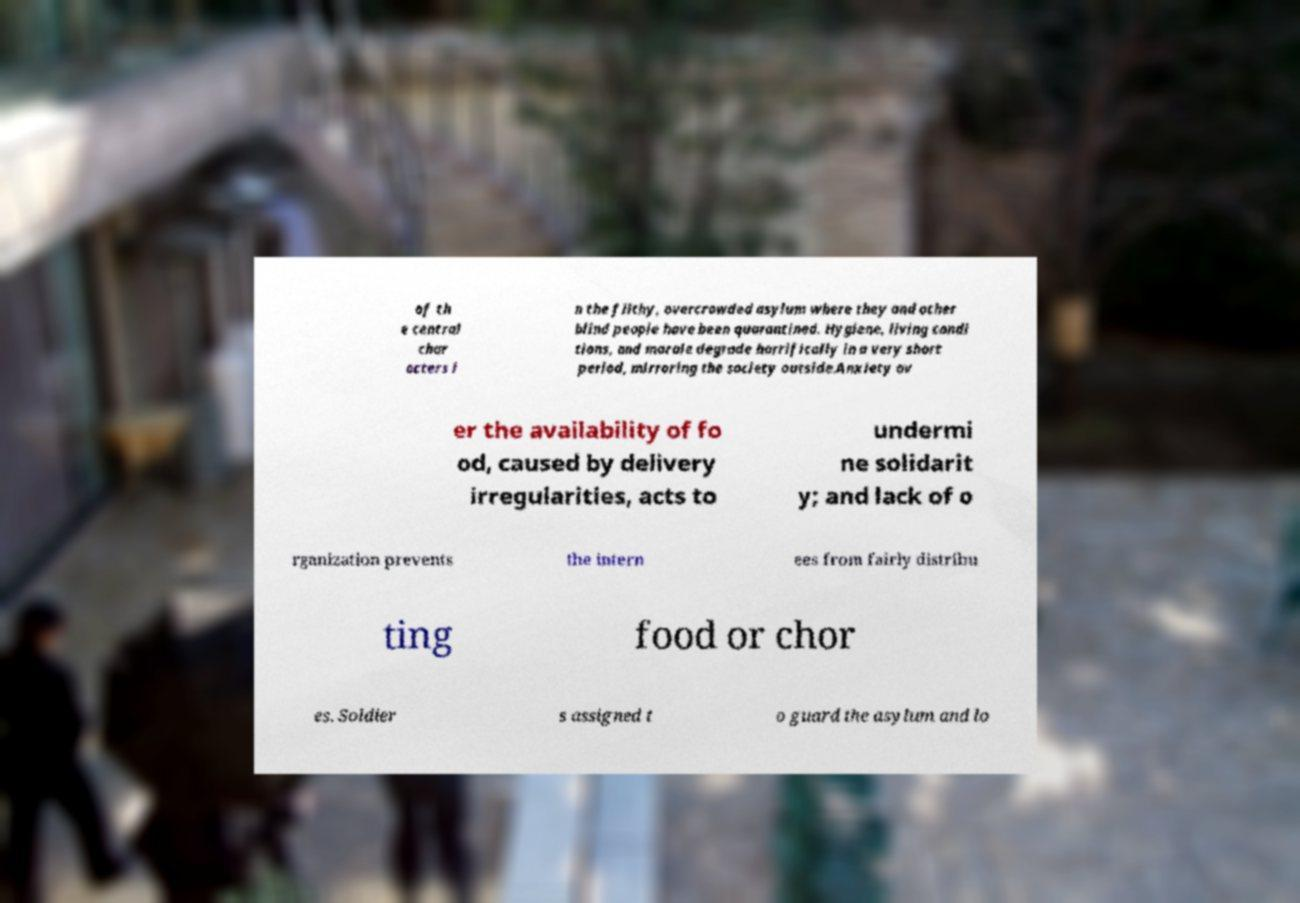There's text embedded in this image that I need extracted. Can you transcribe it verbatim? of th e central char acters i n the filthy, overcrowded asylum where they and other blind people have been quarantined. Hygiene, living condi tions, and morale degrade horrifically in a very short period, mirroring the society outside.Anxiety ov er the availability of fo od, caused by delivery irregularities, acts to undermi ne solidarit y; and lack of o rganization prevents the intern ees from fairly distribu ting food or chor es. Soldier s assigned t o guard the asylum and lo 